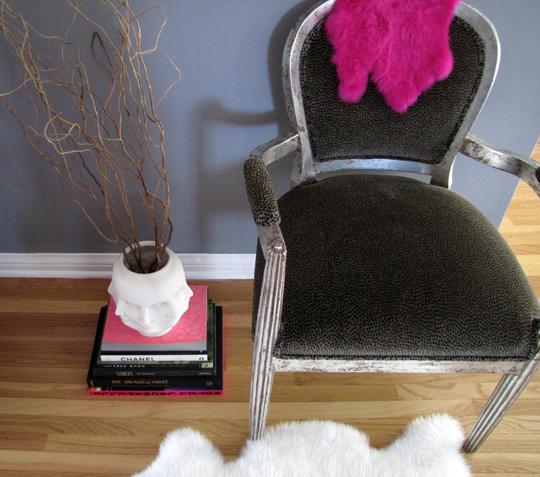What does the shape of the vase resemble?
Keep it brief. Face. How many chairs are there?
Keep it brief. 1. What is the vase sitting on top of?
Short answer required. Books. 